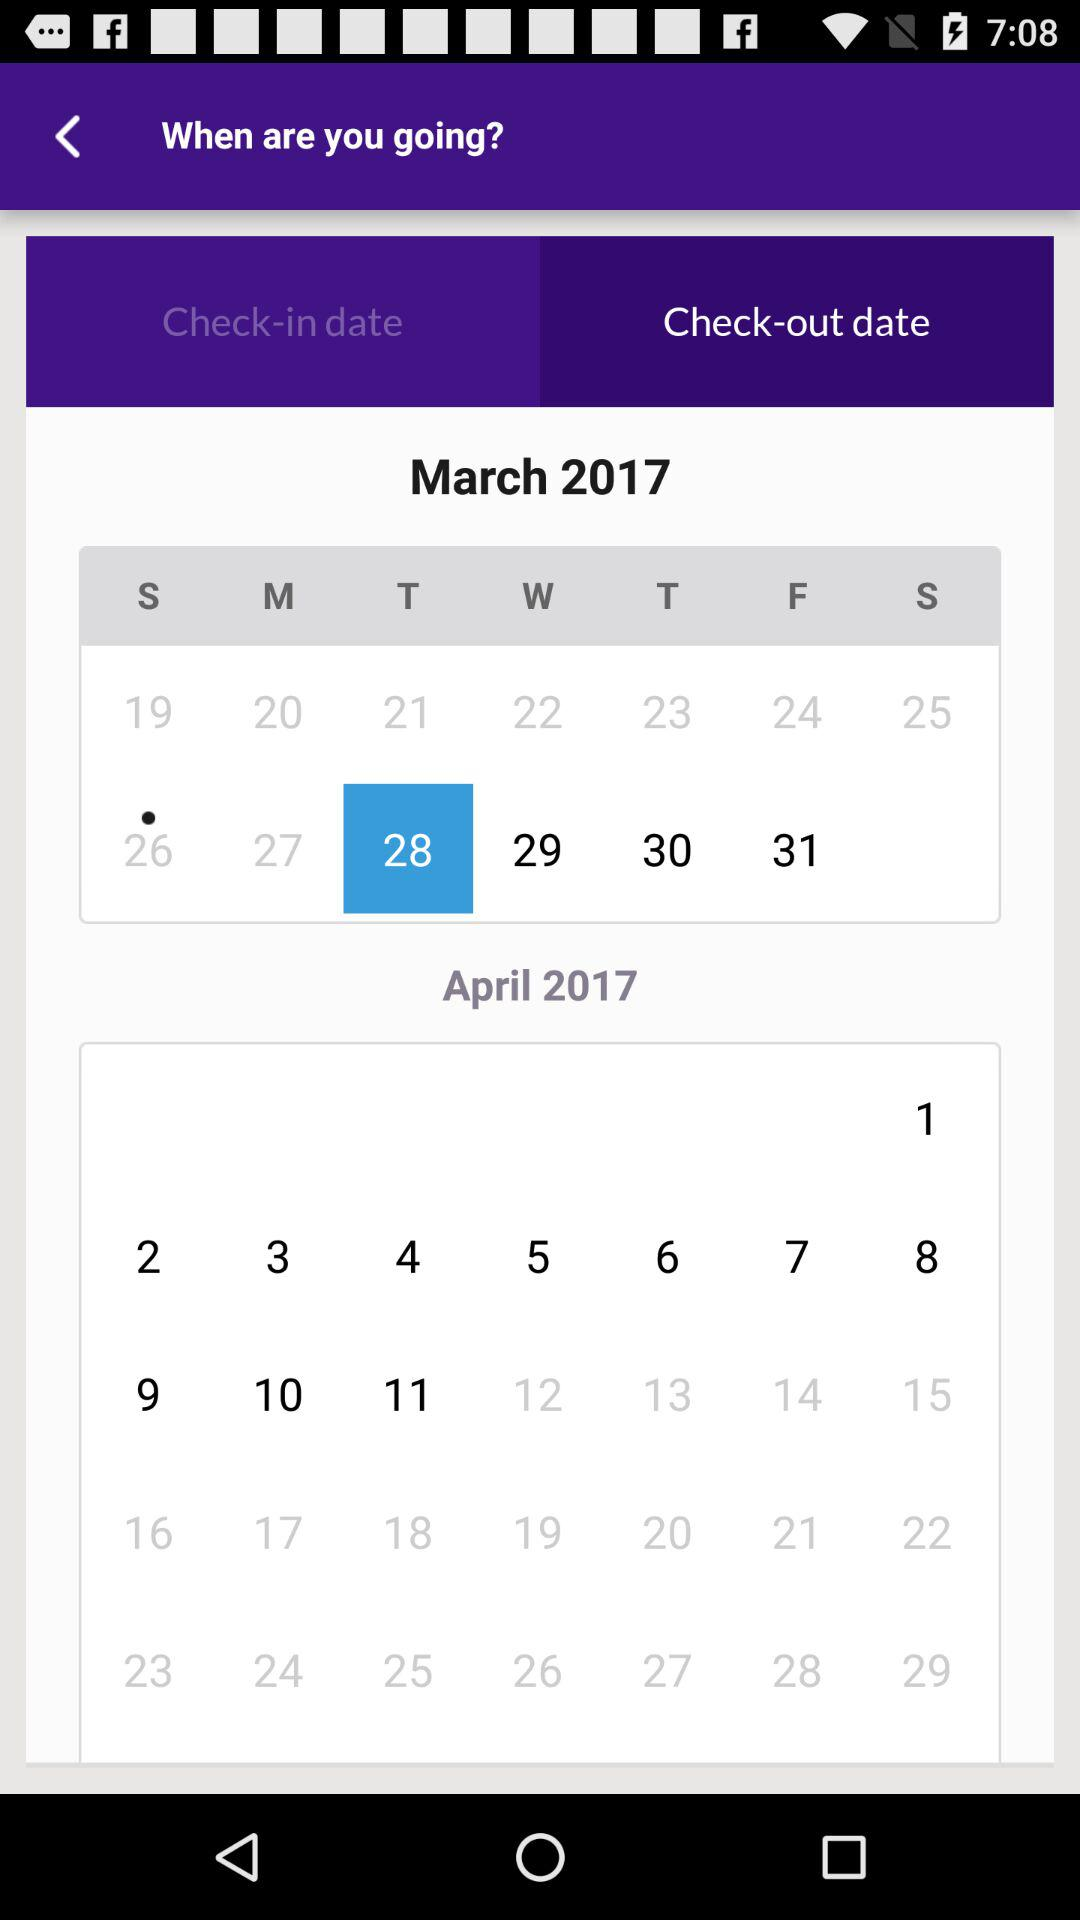What is the check-in date? The check-in date is Sunday, March 26, 2017. 